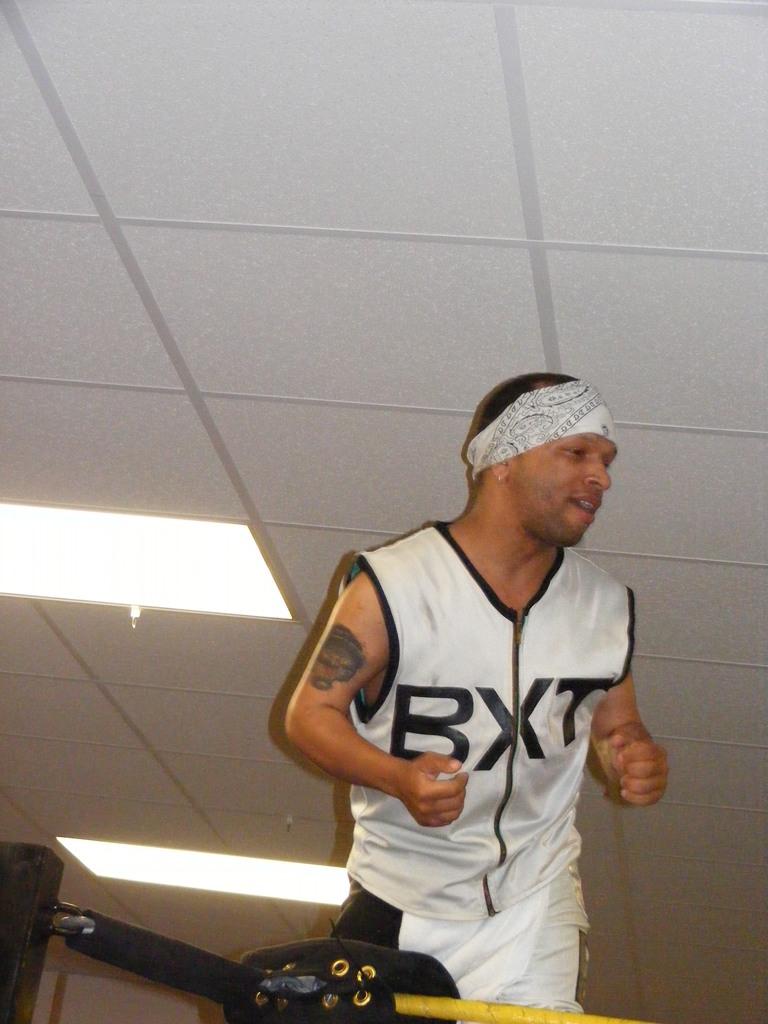What is on his vest?
Your answer should be compact. Bxt. 